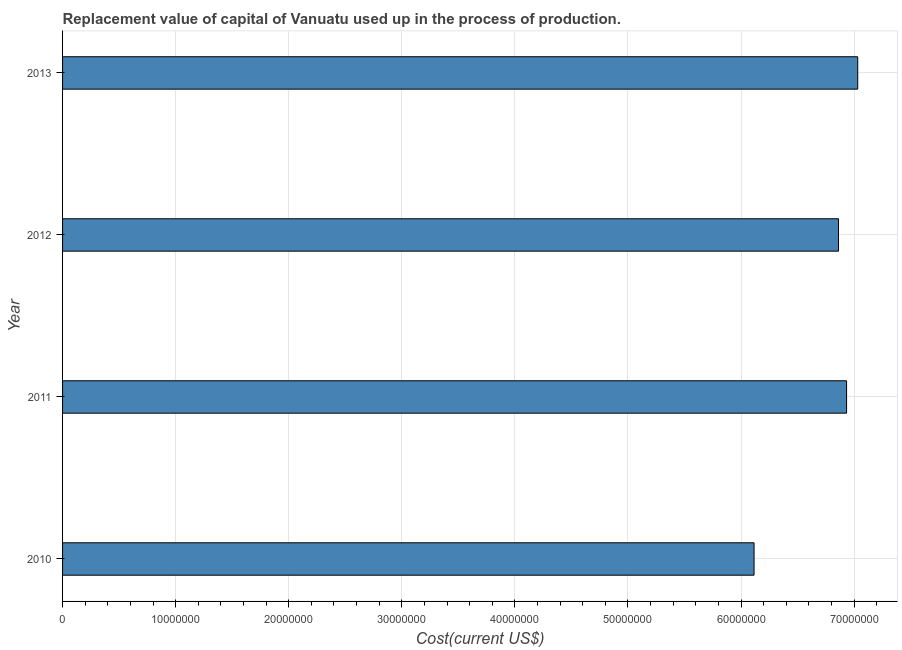Does the graph contain any zero values?
Your answer should be very brief. No. Does the graph contain grids?
Offer a very short reply. Yes. What is the title of the graph?
Your answer should be compact. Replacement value of capital of Vanuatu used up in the process of production. What is the label or title of the X-axis?
Keep it short and to the point. Cost(current US$). What is the label or title of the Y-axis?
Give a very brief answer. Year. What is the consumption of fixed capital in 2012?
Make the answer very short. 6.86e+07. Across all years, what is the maximum consumption of fixed capital?
Offer a very short reply. 7.03e+07. Across all years, what is the minimum consumption of fixed capital?
Ensure brevity in your answer.  6.12e+07. In which year was the consumption of fixed capital maximum?
Make the answer very short. 2013. What is the sum of the consumption of fixed capital?
Keep it short and to the point. 2.69e+08. What is the difference between the consumption of fixed capital in 2012 and 2013?
Your answer should be compact. -1.70e+06. What is the average consumption of fixed capital per year?
Your response must be concise. 6.74e+07. What is the median consumption of fixed capital?
Offer a very short reply. 6.90e+07. Do a majority of the years between 2010 and 2012 (inclusive) have consumption of fixed capital greater than 12000000 US$?
Your answer should be very brief. Yes. What is the ratio of the consumption of fixed capital in 2011 to that in 2013?
Your answer should be very brief. 0.99. Is the difference between the consumption of fixed capital in 2012 and 2013 greater than the difference between any two years?
Offer a terse response. No. What is the difference between the highest and the second highest consumption of fixed capital?
Your answer should be compact. 9.86e+05. Is the sum of the consumption of fixed capital in 2010 and 2013 greater than the maximum consumption of fixed capital across all years?
Your answer should be compact. Yes. What is the difference between the highest and the lowest consumption of fixed capital?
Offer a terse response. 9.17e+06. In how many years, is the consumption of fixed capital greater than the average consumption of fixed capital taken over all years?
Provide a succinct answer. 3. How many bars are there?
Offer a terse response. 4. Are all the bars in the graph horizontal?
Provide a succinct answer. Yes. How many years are there in the graph?
Offer a very short reply. 4. Are the values on the major ticks of X-axis written in scientific E-notation?
Offer a very short reply. No. What is the Cost(current US$) in 2010?
Make the answer very short. 6.12e+07. What is the Cost(current US$) in 2011?
Provide a succinct answer. 6.93e+07. What is the Cost(current US$) of 2012?
Give a very brief answer. 6.86e+07. What is the Cost(current US$) in 2013?
Provide a short and direct response. 7.03e+07. What is the difference between the Cost(current US$) in 2010 and 2011?
Your response must be concise. -8.18e+06. What is the difference between the Cost(current US$) in 2010 and 2012?
Ensure brevity in your answer.  -7.47e+06. What is the difference between the Cost(current US$) in 2010 and 2013?
Offer a very short reply. -9.17e+06. What is the difference between the Cost(current US$) in 2011 and 2012?
Your answer should be compact. 7.16e+05. What is the difference between the Cost(current US$) in 2011 and 2013?
Your answer should be very brief. -9.86e+05. What is the difference between the Cost(current US$) in 2012 and 2013?
Your response must be concise. -1.70e+06. What is the ratio of the Cost(current US$) in 2010 to that in 2011?
Your response must be concise. 0.88. What is the ratio of the Cost(current US$) in 2010 to that in 2012?
Keep it short and to the point. 0.89. What is the ratio of the Cost(current US$) in 2010 to that in 2013?
Ensure brevity in your answer.  0.87. What is the ratio of the Cost(current US$) in 2011 to that in 2013?
Make the answer very short. 0.99. What is the ratio of the Cost(current US$) in 2012 to that in 2013?
Your answer should be compact. 0.98. 